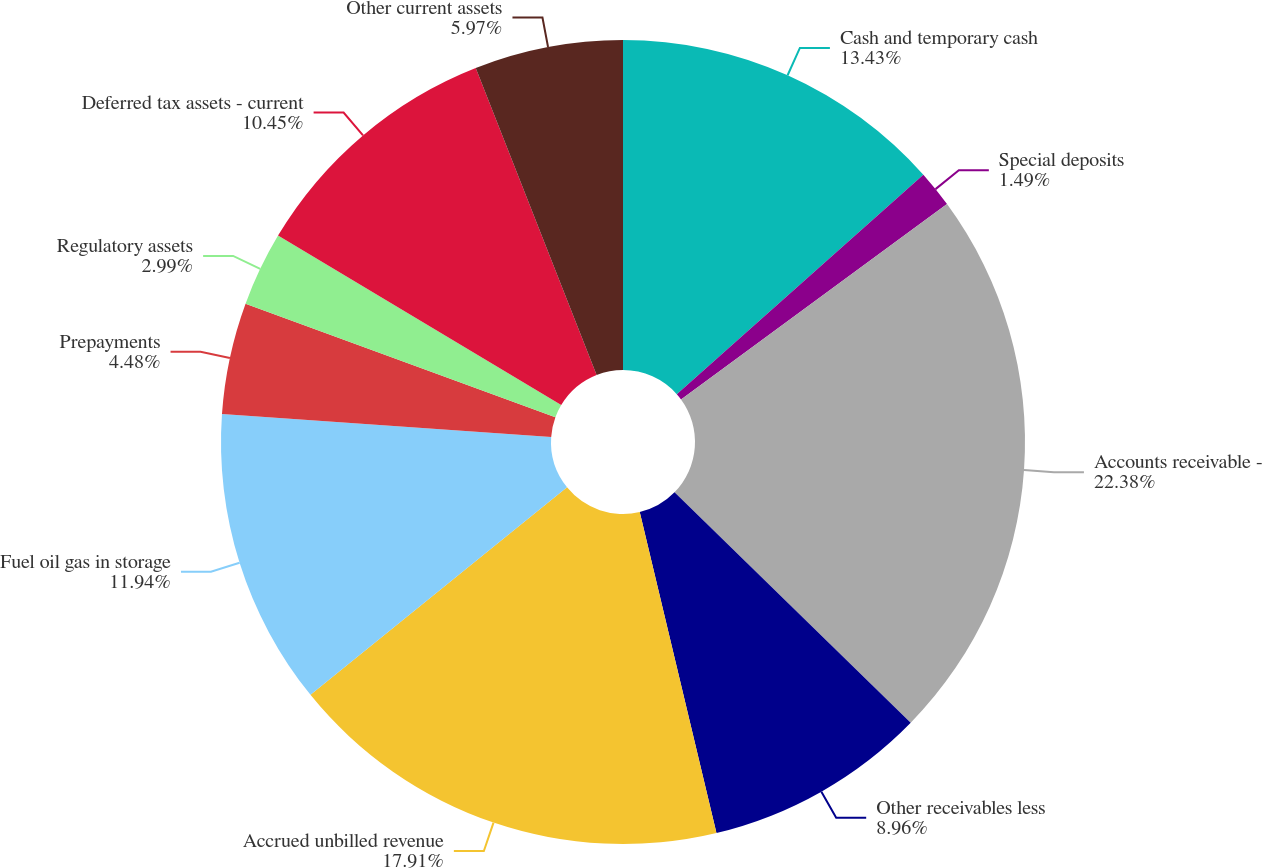<chart> <loc_0><loc_0><loc_500><loc_500><pie_chart><fcel>Cash and temporary cash<fcel>Special deposits<fcel>Accounts receivable -<fcel>Other receivables less<fcel>Accrued unbilled revenue<fcel>Fuel oil gas in storage<fcel>Prepayments<fcel>Regulatory assets<fcel>Deferred tax assets - current<fcel>Other current assets<nl><fcel>13.43%<fcel>1.49%<fcel>22.39%<fcel>8.96%<fcel>17.91%<fcel>11.94%<fcel>4.48%<fcel>2.99%<fcel>10.45%<fcel>5.97%<nl></chart> 